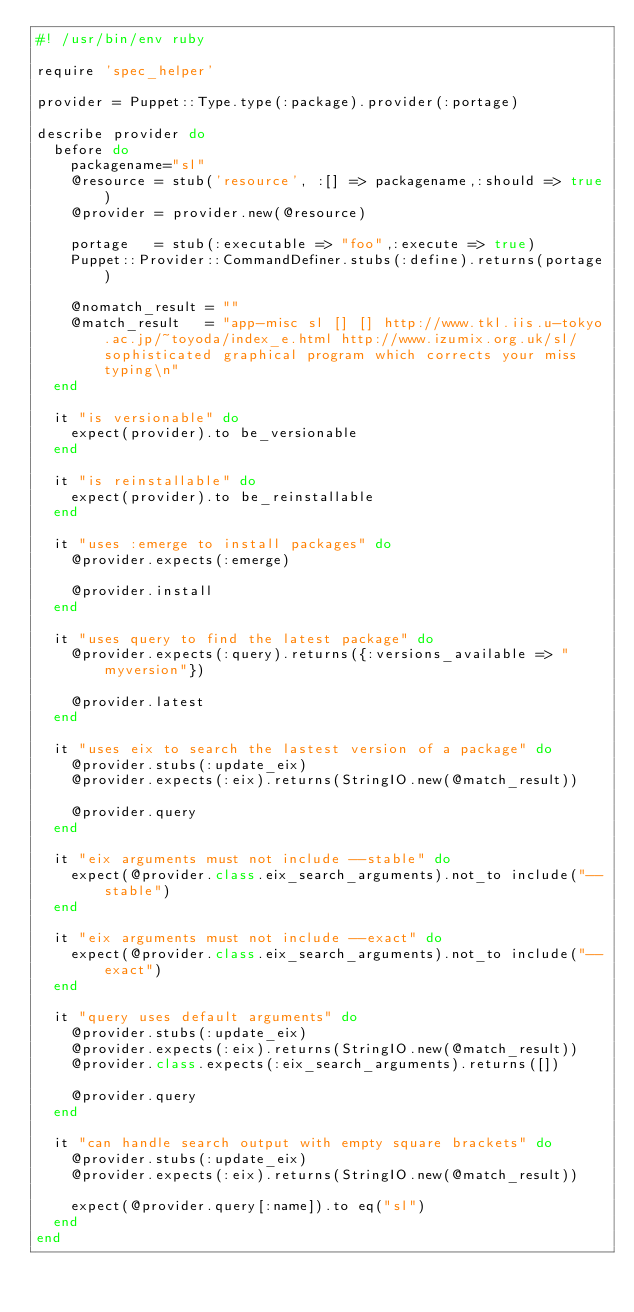<code> <loc_0><loc_0><loc_500><loc_500><_Ruby_>#! /usr/bin/env ruby

require 'spec_helper'

provider = Puppet::Type.type(:package).provider(:portage)

describe provider do
  before do
    packagename="sl"
    @resource = stub('resource', :[] => packagename,:should => true)
    @provider = provider.new(@resource)
    
    portage   = stub(:executable => "foo",:execute => true)
    Puppet::Provider::CommandDefiner.stubs(:define).returns(portage)

    @nomatch_result = ""
    @match_result   = "app-misc sl [] [] http://www.tkl.iis.u-tokyo.ac.jp/~toyoda/index_e.html http://www.izumix.org.uk/sl/ sophisticated graphical program which corrects your miss typing\n"
  end

  it "is versionable" do
    expect(provider).to be_versionable
  end

  it "is reinstallable" do
    expect(provider).to be_reinstallable
  end

  it "uses :emerge to install packages" do
    @provider.expects(:emerge)
    
    @provider.install
  end

  it "uses query to find the latest package" do
    @provider.expects(:query).returns({:versions_available => "myversion"})
    
    @provider.latest
  end

  it "uses eix to search the lastest version of a package" do
    @provider.stubs(:update_eix)
    @provider.expects(:eix).returns(StringIO.new(@match_result))
    
    @provider.query
  end

  it "eix arguments must not include --stable" do
    expect(@provider.class.eix_search_arguments).not_to include("--stable")
  end

  it "eix arguments must not include --exact" do
    expect(@provider.class.eix_search_arguments).not_to include("--exact")
  end

  it "query uses default arguments" do
    @provider.stubs(:update_eix)
    @provider.expects(:eix).returns(StringIO.new(@match_result))
    @provider.class.expects(:eix_search_arguments).returns([])
    
    @provider.query
  end

  it "can handle search output with empty square brackets" do
    @provider.stubs(:update_eix)
    @provider.expects(:eix).returns(StringIO.new(@match_result))
    
    expect(@provider.query[:name]).to eq("sl")
  end
end
</code> 